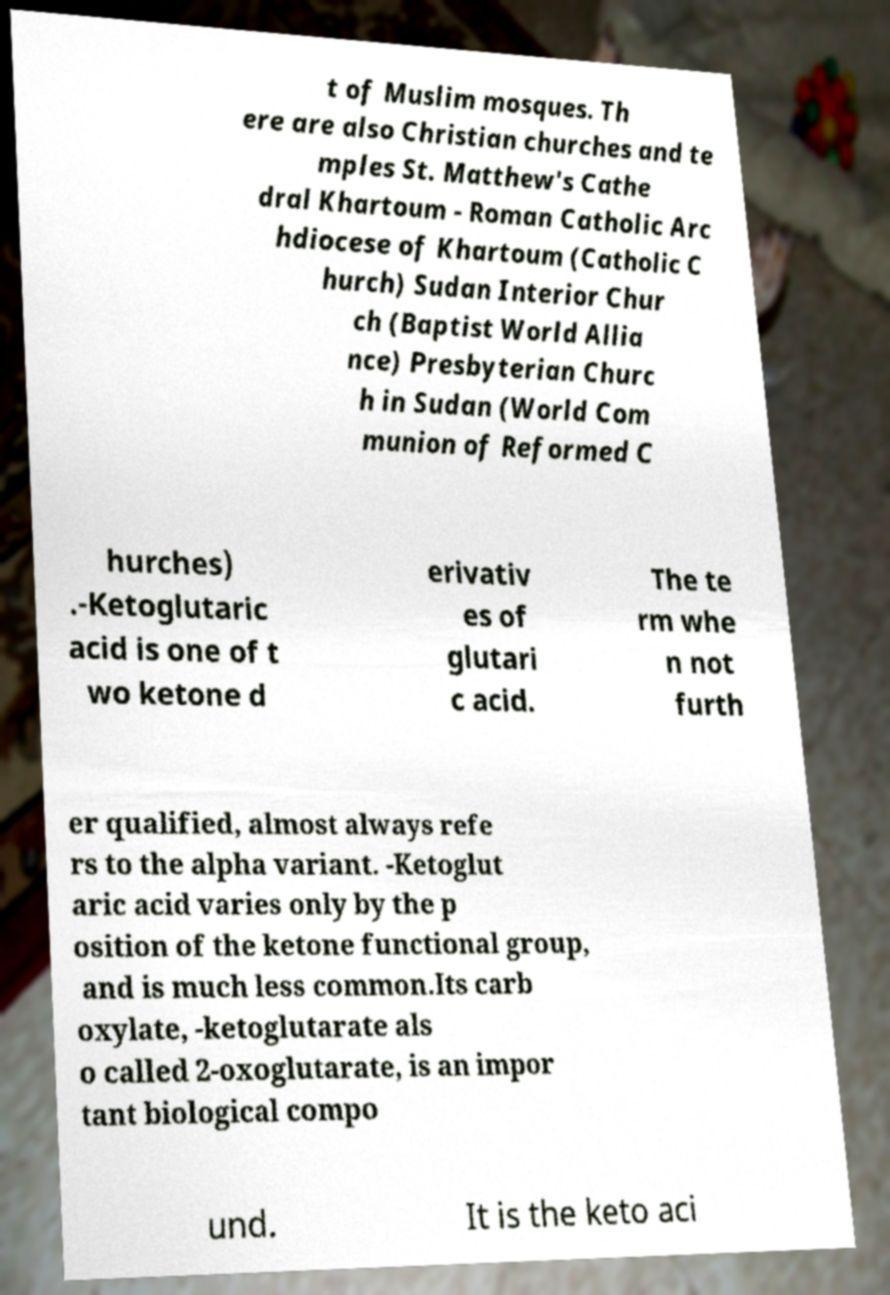Could you extract and type out the text from this image? t of Muslim mosques. Th ere are also Christian churches and te mples St. Matthew's Cathe dral Khartoum - Roman Catholic Arc hdiocese of Khartoum (Catholic C hurch) Sudan Interior Chur ch (Baptist World Allia nce) Presbyterian Churc h in Sudan (World Com munion of Reformed C hurches) .-Ketoglutaric acid is one of t wo ketone d erivativ es of glutari c acid. The te rm whe n not furth er qualified, almost always refe rs to the alpha variant. -Ketoglut aric acid varies only by the p osition of the ketone functional group, and is much less common.Its carb oxylate, -ketoglutarate als o called 2-oxoglutarate, is an impor tant biological compo und. It is the keto aci 